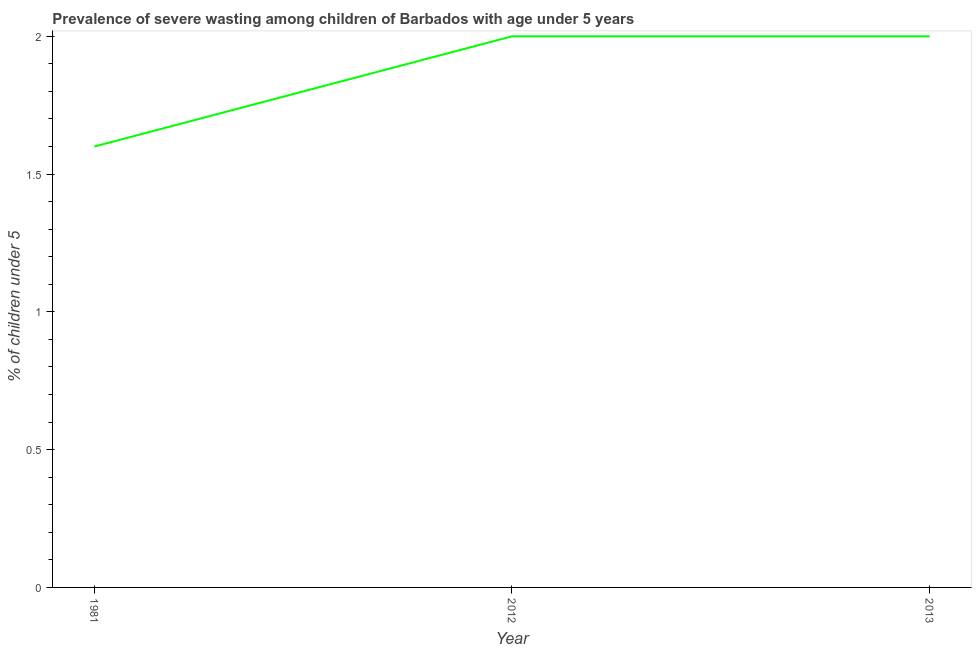What is the prevalence of severe wasting in 2012?
Give a very brief answer. 2. Across all years, what is the minimum prevalence of severe wasting?
Ensure brevity in your answer.  1.6. What is the sum of the prevalence of severe wasting?
Keep it short and to the point. 5.6. What is the difference between the prevalence of severe wasting in 1981 and 2012?
Make the answer very short. -0.4. What is the average prevalence of severe wasting per year?
Provide a succinct answer. 1.87. What is the median prevalence of severe wasting?
Give a very brief answer. 2. In how many years, is the prevalence of severe wasting greater than 1 %?
Your response must be concise. 3. Do a majority of the years between 1981 and 2012 (inclusive) have prevalence of severe wasting greater than 1.3 %?
Give a very brief answer. Yes. What is the ratio of the prevalence of severe wasting in 1981 to that in 2012?
Offer a terse response. 0.8. Is the prevalence of severe wasting in 2012 less than that in 2013?
Provide a succinct answer. No. Is the difference between the prevalence of severe wasting in 1981 and 2012 greater than the difference between any two years?
Your response must be concise. Yes. What is the difference between the highest and the second highest prevalence of severe wasting?
Provide a short and direct response. 0. What is the difference between the highest and the lowest prevalence of severe wasting?
Give a very brief answer. 0.4. How many lines are there?
Give a very brief answer. 1. How many years are there in the graph?
Make the answer very short. 3. Does the graph contain any zero values?
Offer a very short reply. No. What is the title of the graph?
Your answer should be compact. Prevalence of severe wasting among children of Barbados with age under 5 years. What is the label or title of the Y-axis?
Ensure brevity in your answer.   % of children under 5. What is the  % of children under 5 in 1981?
Give a very brief answer. 1.6. What is the  % of children under 5 in 2012?
Offer a terse response. 2. What is the difference between the  % of children under 5 in 1981 and 2012?
Your answer should be very brief. -0.4. What is the difference between the  % of children under 5 in 1981 and 2013?
Provide a short and direct response. -0.4. What is the difference between the  % of children under 5 in 2012 and 2013?
Your answer should be compact. 0. What is the ratio of the  % of children under 5 in 1981 to that in 2012?
Your answer should be very brief. 0.8. What is the ratio of the  % of children under 5 in 1981 to that in 2013?
Your answer should be compact. 0.8. What is the ratio of the  % of children under 5 in 2012 to that in 2013?
Give a very brief answer. 1. 